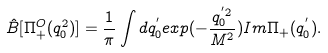Convert formula to latex. <formula><loc_0><loc_0><loc_500><loc_500>\hat { B } [ \Pi _ { + } ^ { O } ( q _ { 0 } ^ { 2 } ) ] = \frac { 1 } { \pi } \int d q _ { 0 } ^ { ^ { \prime } } e x p ( - \frac { q _ { 0 } ^ { ^ { \prime } 2 } } { M ^ { 2 } } ) I m \Pi _ { + } ( q _ { 0 } ^ { ^ { \prime } } ) .</formula> 